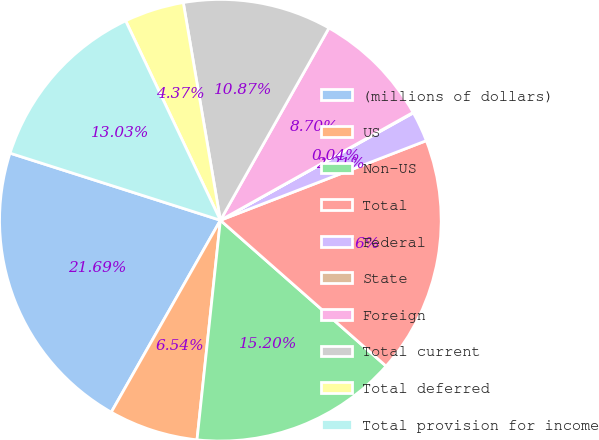Convert chart to OTSL. <chart><loc_0><loc_0><loc_500><loc_500><pie_chart><fcel>(millions of dollars)<fcel>US<fcel>Non-US<fcel>Total<fcel>Federal<fcel>State<fcel>Foreign<fcel>Total current<fcel>Total deferred<fcel>Total provision for income<nl><fcel>21.69%<fcel>6.54%<fcel>15.2%<fcel>17.36%<fcel>2.21%<fcel>0.04%<fcel>8.7%<fcel>10.87%<fcel>4.37%<fcel>13.03%<nl></chart> 